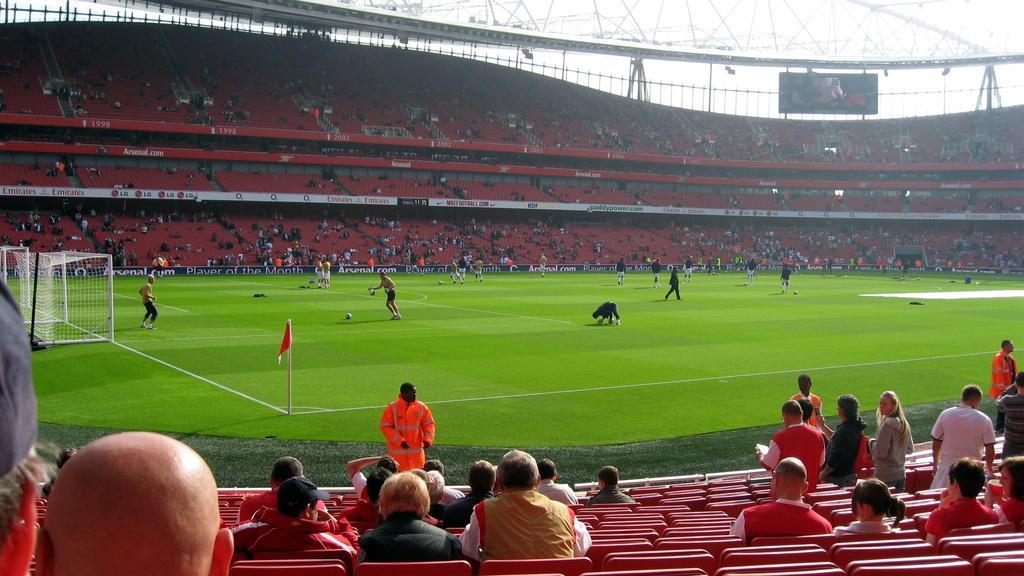In one or two sentences, can you explain what this image depicts? This picture might be taken in a stadium, in this picture at the bottom there are some people who are sitting on chairs and some of them are standing. In the center there are some players who are playing football, and there is one pole and flag. On the left side there is a net and in the background also there are some chairs, poles and boards and some people are sitting and watching the game. On the top of the image there are some poles and hoarding. 